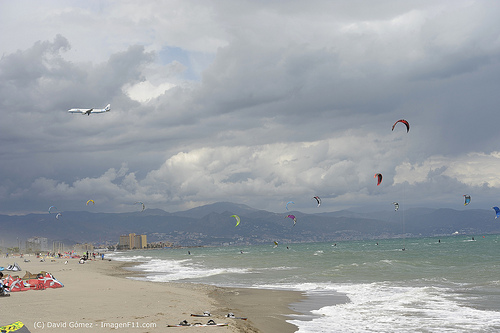Can you describe the activities happening on the beach? The beach is bustling with activities. People are sunbathing, flying kites, and enjoying the waves. The sky is dotted with colorful kites and parachutes, indicating some sort of adventure sport activities like kite surfing or parasailing. Can you elaborate more on the scene at the beach? Certainly! The beach scene is lively with numerous colorful kites flying high in the sky, suggesting a day full of kite surfing activities. The sandy beach stretches long, with people laying out beach towels, umbrellas, and other belongings, indicating they are settled for a long, relaxing day by the sea. In the distance, we can see several buildings, likely beachfront hotels or apartments, accommodating tourists and visitors. The sea itself is a palette of blues and greens, with gentle waves lapping against the shore. The backdrop features a range of mountains under a slightly overcast sky, adding a dramatic touch to the scene. Imagine a children’s book story from this beach scene. Once upon a time, on a beautiful beach guarded by mysterious misty mountains, children played under an endlessly blue sky adorned with colorful kites. Each kite told its own story. One day, little Sara, with her bright red kite that looked like a soaring dragon, met Daniel, whose blue butterfly kite danced gracefully among the clouds. Together, they discovered that their kites held magical powers. Sara’s dragon kite could breathe fire, and Daniel’s butterfly kite could sprinkle sparkling dust that brought peace and joy. They embarked on adventures, saving beachgoers from the mischievous pranks of the Wind Wizard who loved to tangle kites. They soared high above the clouds, exploring enchanted lands with sea creatures and hidden treasures, learning about bravery, friendship, and the magic that lies within a child's imagination. 